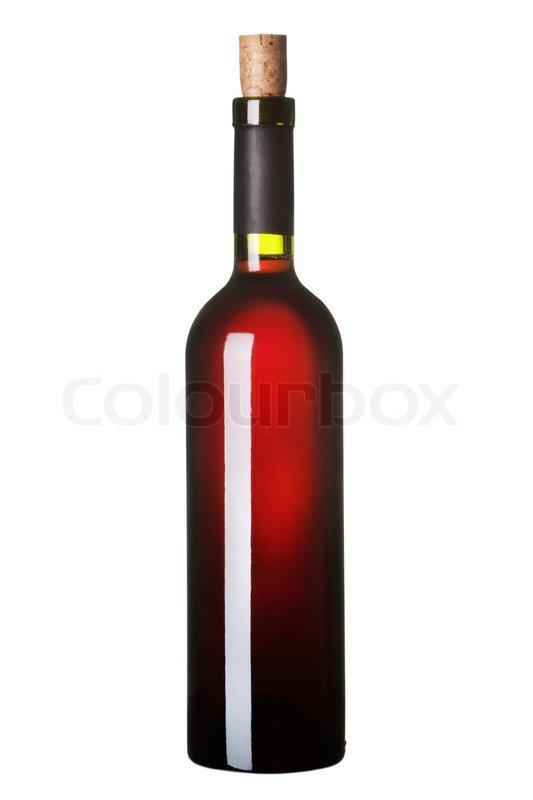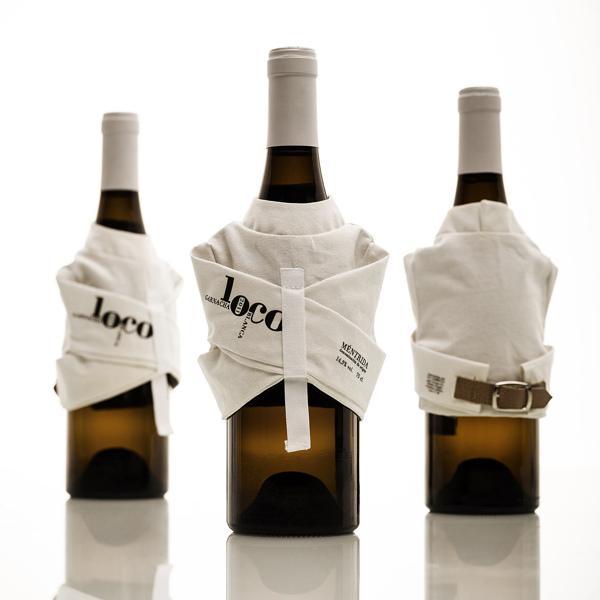The first image is the image on the left, the second image is the image on the right. Evaluate the accuracy of this statement regarding the images: "There is one wine bottle in the left image.". Is it true? Answer yes or no. Yes. The first image is the image on the left, the second image is the image on the right. Analyze the images presented: Is the assertion "Exactly one bottle of wine is standing in one image." valid? Answer yes or no. Yes. 